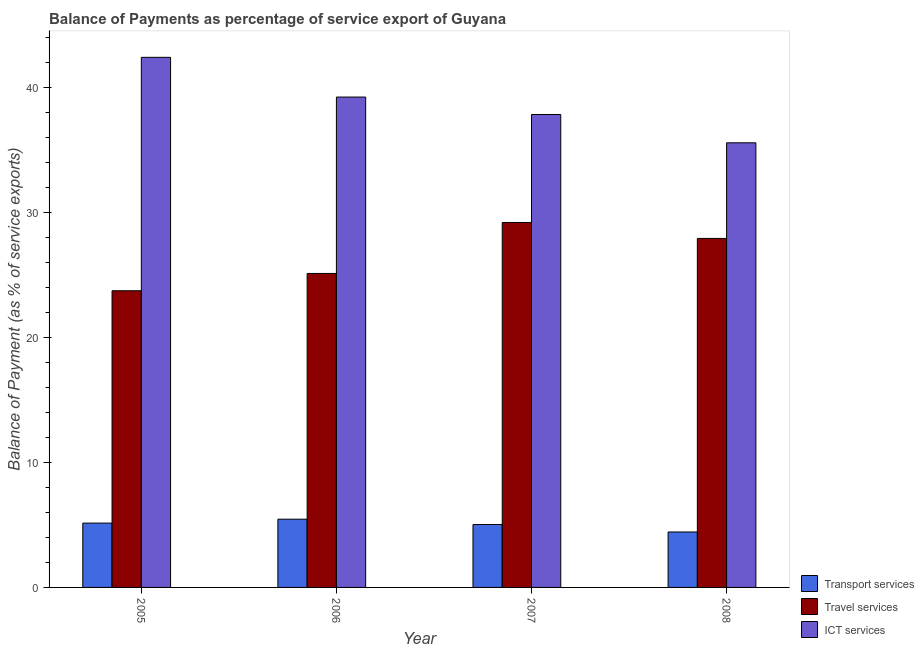How many different coloured bars are there?
Offer a very short reply. 3. Are the number of bars on each tick of the X-axis equal?
Make the answer very short. Yes. What is the balance of payment of transport services in 2008?
Provide a short and direct response. 4.44. Across all years, what is the maximum balance of payment of travel services?
Your answer should be compact. 29.2. Across all years, what is the minimum balance of payment of transport services?
Provide a succinct answer. 4.44. In which year was the balance of payment of ict services minimum?
Offer a terse response. 2008. What is the total balance of payment of transport services in the graph?
Give a very brief answer. 20.08. What is the difference between the balance of payment of travel services in 2005 and that in 2008?
Provide a short and direct response. -4.19. What is the difference between the balance of payment of transport services in 2006 and the balance of payment of ict services in 2008?
Offer a terse response. 1.02. What is the average balance of payment of ict services per year?
Offer a very short reply. 38.76. In the year 2006, what is the difference between the balance of payment of ict services and balance of payment of travel services?
Make the answer very short. 0. In how many years, is the balance of payment of ict services greater than 24 %?
Give a very brief answer. 4. What is the ratio of the balance of payment of travel services in 2007 to that in 2008?
Your response must be concise. 1.05. Is the balance of payment of transport services in 2005 less than that in 2006?
Your response must be concise. Yes. What is the difference between the highest and the second highest balance of payment of travel services?
Offer a very short reply. 1.28. What is the difference between the highest and the lowest balance of payment of transport services?
Provide a succinct answer. 1.02. What does the 1st bar from the left in 2006 represents?
Provide a succinct answer. Transport services. What does the 2nd bar from the right in 2006 represents?
Provide a short and direct response. Travel services. Is it the case that in every year, the sum of the balance of payment of transport services and balance of payment of travel services is greater than the balance of payment of ict services?
Provide a short and direct response. No. Are all the bars in the graph horizontal?
Give a very brief answer. No. How many years are there in the graph?
Your answer should be very brief. 4. What is the difference between two consecutive major ticks on the Y-axis?
Offer a very short reply. 10. Are the values on the major ticks of Y-axis written in scientific E-notation?
Offer a terse response. No. Does the graph contain any zero values?
Make the answer very short. No. Where does the legend appear in the graph?
Keep it short and to the point. Bottom right. What is the title of the graph?
Provide a short and direct response. Balance of Payments as percentage of service export of Guyana. What is the label or title of the X-axis?
Provide a succinct answer. Year. What is the label or title of the Y-axis?
Your answer should be compact. Balance of Payment (as % of service exports). What is the Balance of Payment (as % of service exports) of Transport services in 2005?
Ensure brevity in your answer.  5.15. What is the Balance of Payment (as % of service exports) in Travel services in 2005?
Give a very brief answer. 23.73. What is the Balance of Payment (as % of service exports) of ICT services in 2005?
Keep it short and to the point. 42.41. What is the Balance of Payment (as % of service exports) of Transport services in 2006?
Your answer should be compact. 5.46. What is the Balance of Payment (as % of service exports) of Travel services in 2006?
Provide a succinct answer. 25.12. What is the Balance of Payment (as % of service exports) in ICT services in 2006?
Give a very brief answer. 39.23. What is the Balance of Payment (as % of service exports) of Transport services in 2007?
Your answer should be compact. 5.03. What is the Balance of Payment (as % of service exports) of Travel services in 2007?
Your answer should be compact. 29.2. What is the Balance of Payment (as % of service exports) in ICT services in 2007?
Offer a terse response. 37.84. What is the Balance of Payment (as % of service exports) in Transport services in 2008?
Your answer should be compact. 4.44. What is the Balance of Payment (as % of service exports) of Travel services in 2008?
Offer a terse response. 27.92. What is the Balance of Payment (as % of service exports) of ICT services in 2008?
Your answer should be compact. 35.57. Across all years, what is the maximum Balance of Payment (as % of service exports) of Transport services?
Your response must be concise. 5.46. Across all years, what is the maximum Balance of Payment (as % of service exports) of Travel services?
Your answer should be compact. 29.2. Across all years, what is the maximum Balance of Payment (as % of service exports) of ICT services?
Offer a terse response. 42.41. Across all years, what is the minimum Balance of Payment (as % of service exports) in Transport services?
Offer a terse response. 4.44. Across all years, what is the minimum Balance of Payment (as % of service exports) of Travel services?
Offer a terse response. 23.73. Across all years, what is the minimum Balance of Payment (as % of service exports) of ICT services?
Your answer should be compact. 35.57. What is the total Balance of Payment (as % of service exports) of Transport services in the graph?
Your answer should be very brief. 20.08. What is the total Balance of Payment (as % of service exports) in Travel services in the graph?
Your answer should be compact. 105.97. What is the total Balance of Payment (as % of service exports) of ICT services in the graph?
Your answer should be compact. 155.04. What is the difference between the Balance of Payment (as % of service exports) of Transport services in 2005 and that in 2006?
Offer a terse response. -0.31. What is the difference between the Balance of Payment (as % of service exports) of Travel services in 2005 and that in 2006?
Provide a succinct answer. -1.38. What is the difference between the Balance of Payment (as % of service exports) in ICT services in 2005 and that in 2006?
Your response must be concise. 3.18. What is the difference between the Balance of Payment (as % of service exports) of Transport services in 2005 and that in 2007?
Your answer should be very brief. 0.11. What is the difference between the Balance of Payment (as % of service exports) of Travel services in 2005 and that in 2007?
Your response must be concise. -5.46. What is the difference between the Balance of Payment (as % of service exports) of ICT services in 2005 and that in 2007?
Provide a succinct answer. 4.57. What is the difference between the Balance of Payment (as % of service exports) in Transport services in 2005 and that in 2008?
Keep it short and to the point. 0.71. What is the difference between the Balance of Payment (as % of service exports) of Travel services in 2005 and that in 2008?
Ensure brevity in your answer.  -4.19. What is the difference between the Balance of Payment (as % of service exports) of ICT services in 2005 and that in 2008?
Your answer should be very brief. 6.84. What is the difference between the Balance of Payment (as % of service exports) of Transport services in 2006 and that in 2007?
Your response must be concise. 0.42. What is the difference between the Balance of Payment (as % of service exports) of Travel services in 2006 and that in 2007?
Make the answer very short. -4.08. What is the difference between the Balance of Payment (as % of service exports) in ICT services in 2006 and that in 2007?
Keep it short and to the point. 1.39. What is the difference between the Balance of Payment (as % of service exports) in Transport services in 2006 and that in 2008?
Ensure brevity in your answer.  1.02. What is the difference between the Balance of Payment (as % of service exports) of Travel services in 2006 and that in 2008?
Offer a very short reply. -2.8. What is the difference between the Balance of Payment (as % of service exports) of ICT services in 2006 and that in 2008?
Your answer should be compact. 3.66. What is the difference between the Balance of Payment (as % of service exports) of Transport services in 2007 and that in 2008?
Provide a succinct answer. 0.6. What is the difference between the Balance of Payment (as % of service exports) of Travel services in 2007 and that in 2008?
Offer a terse response. 1.28. What is the difference between the Balance of Payment (as % of service exports) in ICT services in 2007 and that in 2008?
Your response must be concise. 2.27. What is the difference between the Balance of Payment (as % of service exports) in Transport services in 2005 and the Balance of Payment (as % of service exports) in Travel services in 2006?
Your answer should be compact. -19.97. What is the difference between the Balance of Payment (as % of service exports) of Transport services in 2005 and the Balance of Payment (as % of service exports) of ICT services in 2006?
Provide a short and direct response. -34.08. What is the difference between the Balance of Payment (as % of service exports) in Travel services in 2005 and the Balance of Payment (as % of service exports) in ICT services in 2006?
Provide a succinct answer. -15.5. What is the difference between the Balance of Payment (as % of service exports) in Transport services in 2005 and the Balance of Payment (as % of service exports) in Travel services in 2007?
Give a very brief answer. -24.05. What is the difference between the Balance of Payment (as % of service exports) of Transport services in 2005 and the Balance of Payment (as % of service exports) of ICT services in 2007?
Keep it short and to the point. -32.69. What is the difference between the Balance of Payment (as % of service exports) of Travel services in 2005 and the Balance of Payment (as % of service exports) of ICT services in 2007?
Keep it short and to the point. -14.1. What is the difference between the Balance of Payment (as % of service exports) in Transport services in 2005 and the Balance of Payment (as % of service exports) in Travel services in 2008?
Make the answer very short. -22.77. What is the difference between the Balance of Payment (as % of service exports) of Transport services in 2005 and the Balance of Payment (as % of service exports) of ICT services in 2008?
Offer a terse response. -30.42. What is the difference between the Balance of Payment (as % of service exports) in Travel services in 2005 and the Balance of Payment (as % of service exports) in ICT services in 2008?
Ensure brevity in your answer.  -11.84. What is the difference between the Balance of Payment (as % of service exports) of Transport services in 2006 and the Balance of Payment (as % of service exports) of Travel services in 2007?
Make the answer very short. -23.74. What is the difference between the Balance of Payment (as % of service exports) of Transport services in 2006 and the Balance of Payment (as % of service exports) of ICT services in 2007?
Ensure brevity in your answer.  -32.38. What is the difference between the Balance of Payment (as % of service exports) of Travel services in 2006 and the Balance of Payment (as % of service exports) of ICT services in 2007?
Provide a succinct answer. -12.72. What is the difference between the Balance of Payment (as % of service exports) of Transport services in 2006 and the Balance of Payment (as % of service exports) of Travel services in 2008?
Offer a terse response. -22.46. What is the difference between the Balance of Payment (as % of service exports) in Transport services in 2006 and the Balance of Payment (as % of service exports) in ICT services in 2008?
Keep it short and to the point. -30.11. What is the difference between the Balance of Payment (as % of service exports) in Travel services in 2006 and the Balance of Payment (as % of service exports) in ICT services in 2008?
Keep it short and to the point. -10.45. What is the difference between the Balance of Payment (as % of service exports) of Transport services in 2007 and the Balance of Payment (as % of service exports) of Travel services in 2008?
Offer a very short reply. -22.89. What is the difference between the Balance of Payment (as % of service exports) in Transport services in 2007 and the Balance of Payment (as % of service exports) in ICT services in 2008?
Your response must be concise. -30.54. What is the difference between the Balance of Payment (as % of service exports) of Travel services in 2007 and the Balance of Payment (as % of service exports) of ICT services in 2008?
Keep it short and to the point. -6.37. What is the average Balance of Payment (as % of service exports) in Transport services per year?
Your answer should be compact. 5.02. What is the average Balance of Payment (as % of service exports) of Travel services per year?
Provide a short and direct response. 26.49. What is the average Balance of Payment (as % of service exports) of ICT services per year?
Offer a terse response. 38.76. In the year 2005, what is the difference between the Balance of Payment (as % of service exports) in Transport services and Balance of Payment (as % of service exports) in Travel services?
Provide a short and direct response. -18.59. In the year 2005, what is the difference between the Balance of Payment (as % of service exports) in Transport services and Balance of Payment (as % of service exports) in ICT services?
Offer a very short reply. -37.26. In the year 2005, what is the difference between the Balance of Payment (as % of service exports) in Travel services and Balance of Payment (as % of service exports) in ICT services?
Your response must be concise. -18.67. In the year 2006, what is the difference between the Balance of Payment (as % of service exports) in Transport services and Balance of Payment (as % of service exports) in Travel services?
Offer a very short reply. -19.66. In the year 2006, what is the difference between the Balance of Payment (as % of service exports) of Transport services and Balance of Payment (as % of service exports) of ICT services?
Provide a succinct answer. -33.77. In the year 2006, what is the difference between the Balance of Payment (as % of service exports) in Travel services and Balance of Payment (as % of service exports) in ICT services?
Your response must be concise. -14.11. In the year 2007, what is the difference between the Balance of Payment (as % of service exports) of Transport services and Balance of Payment (as % of service exports) of Travel services?
Keep it short and to the point. -24.16. In the year 2007, what is the difference between the Balance of Payment (as % of service exports) in Transport services and Balance of Payment (as % of service exports) in ICT services?
Offer a very short reply. -32.8. In the year 2007, what is the difference between the Balance of Payment (as % of service exports) in Travel services and Balance of Payment (as % of service exports) in ICT services?
Provide a succinct answer. -8.64. In the year 2008, what is the difference between the Balance of Payment (as % of service exports) in Transport services and Balance of Payment (as % of service exports) in Travel services?
Offer a terse response. -23.48. In the year 2008, what is the difference between the Balance of Payment (as % of service exports) in Transport services and Balance of Payment (as % of service exports) in ICT services?
Give a very brief answer. -31.13. In the year 2008, what is the difference between the Balance of Payment (as % of service exports) in Travel services and Balance of Payment (as % of service exports) in ICT services?
Keep it short and to the point. -7.65. What is the ratio of the Balance of Payment (as % of service exports) of Transport services in 2005 to that in 2006?
Make the answer very short. 0.94. What is the ratio of the Balance of Payment (as % of service exports) of Travel services in 2005 to that in 2006?
Keep it short and to the point. 0.94. What is the ratio of the Balance of Payment (as % of service exports) of ICT services in 2005 to that in 2006?
Offer a very short reply. 1.08. What is the ratio of the Balance of Payment (as % of service exports) of Transport services in 2005 to that in 2007?
Keep it short and to the point. 1.02. What is the ratio of the Balance of Payment (as % of service exports) of Travel services in 2005 to that in 2007?
Offer a very short reply. 0.81. What is the ratio of the Balance of Payment (as % of service exports) of ICT services in 2005 to that in 2007?
Provide a short and direct response. 1.12. What is the ratio of the Balance of Payment (as % of service exports) in Transport services in 2005 to that in 2008?
Keep it short and to the point. 1.16. What is the ratio of the Balance of Payment (as % of service exports) in Travel services in 2005 to that in 2008?
Your response must be concise. 0.85. What is the ratio of the Balance of Payment (as % of service exports) of ICT services in 2005 to that in 2008?
Give a very brief answer. 1.19. What is the ratio of the Balance of Payment (as % of service exports) of Transport services in 2006 to that in 2007?
Offer a very short reply. 1.08. What is the ratio of the Balance of Payment (as % of service exports) in Travel services in 2006 to that in 2007?
Give a very brief answer. 0.86. What is the ratio of the Balance of Payment (as % of service exports) of ICT services in 2006 to that in 2007?
Make the answer very short. 1.04. What is the ratio of the Balance of Payment (as % of service exports) in Transport services in 2006 to that in 2008?
Offer a terse response. 1.23. What is the ratio of the Balance of Payment (as % of service exports) of Travel services in 2006 to that in 2008?
Provide a short and direct response. 0.9. What is the ratio of the Balance of Payment (as % of service exports) in ICT services in 2006 to that in 2008?
Offer a terse response. 1.1. What is the ratio of the Balance of Payment (as % of service exports) of Transport services in 2007 to that in 2008?
Make the answer very short. 1.13. What is the ratio of the Balance of Payment (as % of service exports) of Travel services in 2007 to that in 2008?
Offer a terse response. 1.05. What is the ratio of the Balance of Payment (as % of service exports) in ICT services in 2007 to that in 2008?
Provide a succinct answer. 1.06. What is the difference between the highest and the second highest Balance of Payment (as % of service exports) of Transport services?
Your response must be concise. 0.31. What is the difference between the highest and the second highest Balance of Payment (as % of service exports) of Travel services?
Your response must be concise. 1.28. What is the difference between the highest and the second highest Balance of Payment (as % of service exports) in ICT services?
Make the answer very short. 3.18. What is the difference between the highest and the lowest Balance of Payment (as % of service exports) in Transport services?
Make the answer very short. 1.02. What is the difference between the highest and the lowest Balance of Payment (as % of service exports) in Travel services?
Your response must be concise. 5.46. What is the difference between the highest and the lowest Balance of Payment (as % of service exports) of ICT services?
Make the answer very short. 6.84. 